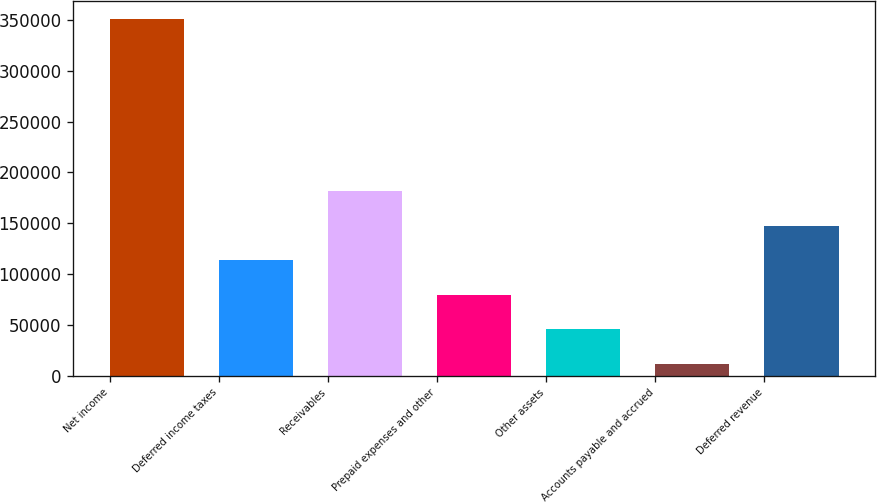<chart> <loc_0><loc_0><loc_500><loc_500><bar_chart><fcel>Net income<fcel>Deferred income taxes<fcel>Receivables<fcel>Prepaid expenses and other<fcel>Other assets<fcel>Accounts payable and accrued<fcel>Deferred revenue<nl><fcel>351297<fcel>113546<fcel>181475<fcel>79581.8<fcel>45617.4<fcel>11653<fcel>147511<nl></chart> 